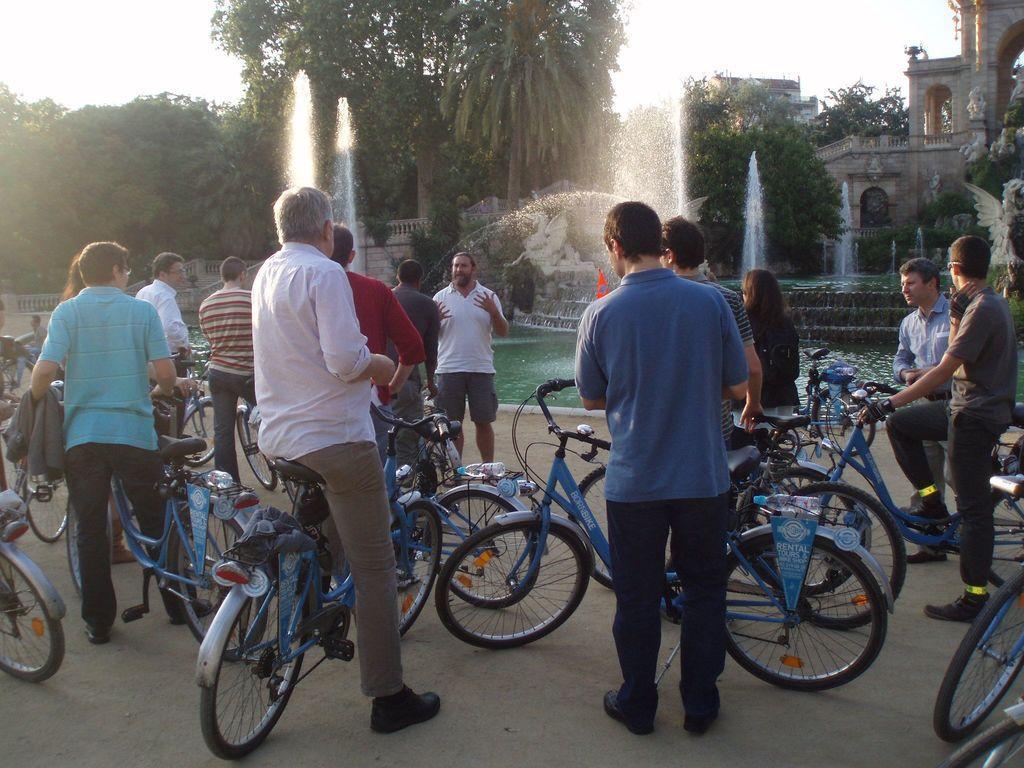Can you describe this image briefly? In this image there are many people , In the middle there is a man he wear a white t shirt and trouser he is speaking something. On the right there are two man they sited on the cycles they are staring at something. In the middle there is a man he wear a t shirt and trouser. In the middle there is a man he wear a white t shirt and trouser he is sitting on the cycle. In the back ground there is water ,there are trees ,fountain ,house and steps. 